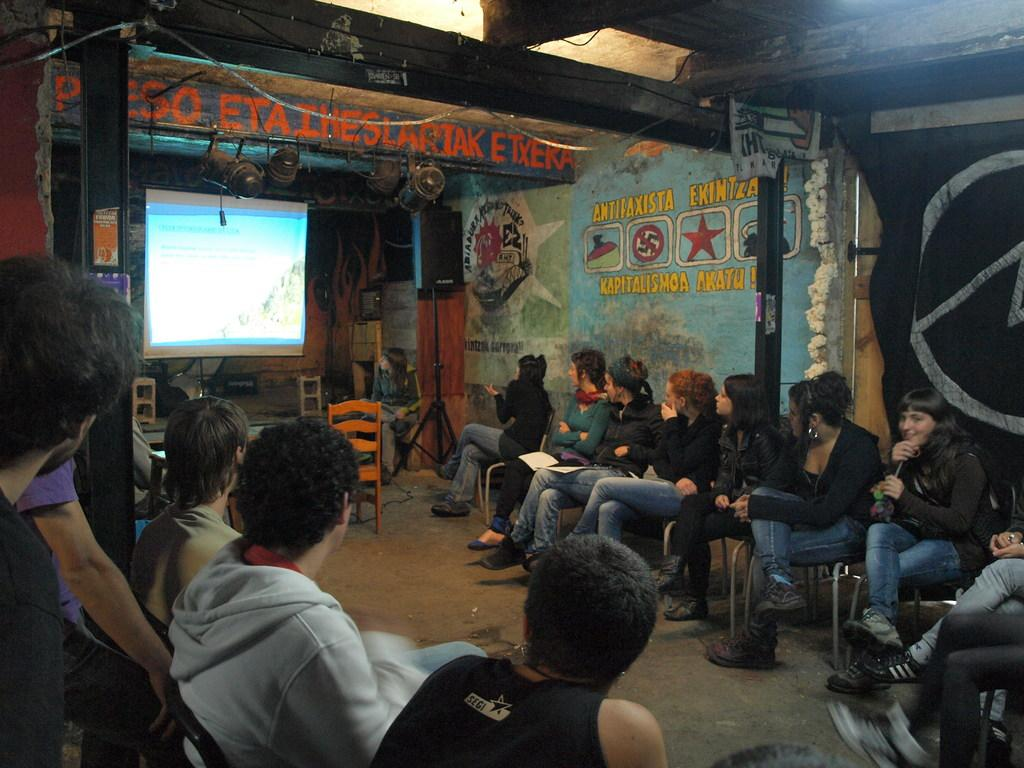How many people are in the image? There is a group of people in the image. What are the people doing in the image? The people are sitting on chairs and watching something on the projector screen. What is the purpose of the projector screen in the image? The projector screen is being used to display something for the group of people to watch. What device might be used to amplify sound in the image? There is a speaker present in the image. What type of quince is being served to the people in the image? There is no quince present in the image; the people are watching something on the projector screen. 